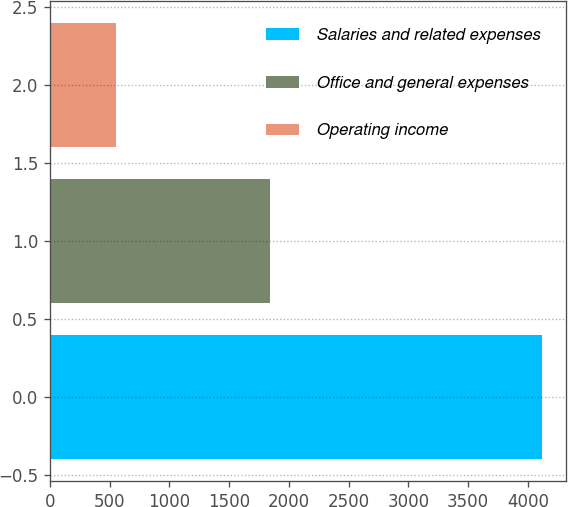Convert chart. <chart><loc_0><loc_0><loc_500><loc_500><bar_chart><fcel>Salaries and related expenses<fcel>Office and general expenses<fcel>Operating income<nl><fcel>4117<fcel>1841.6<fcel>548.7<nl></chart> 